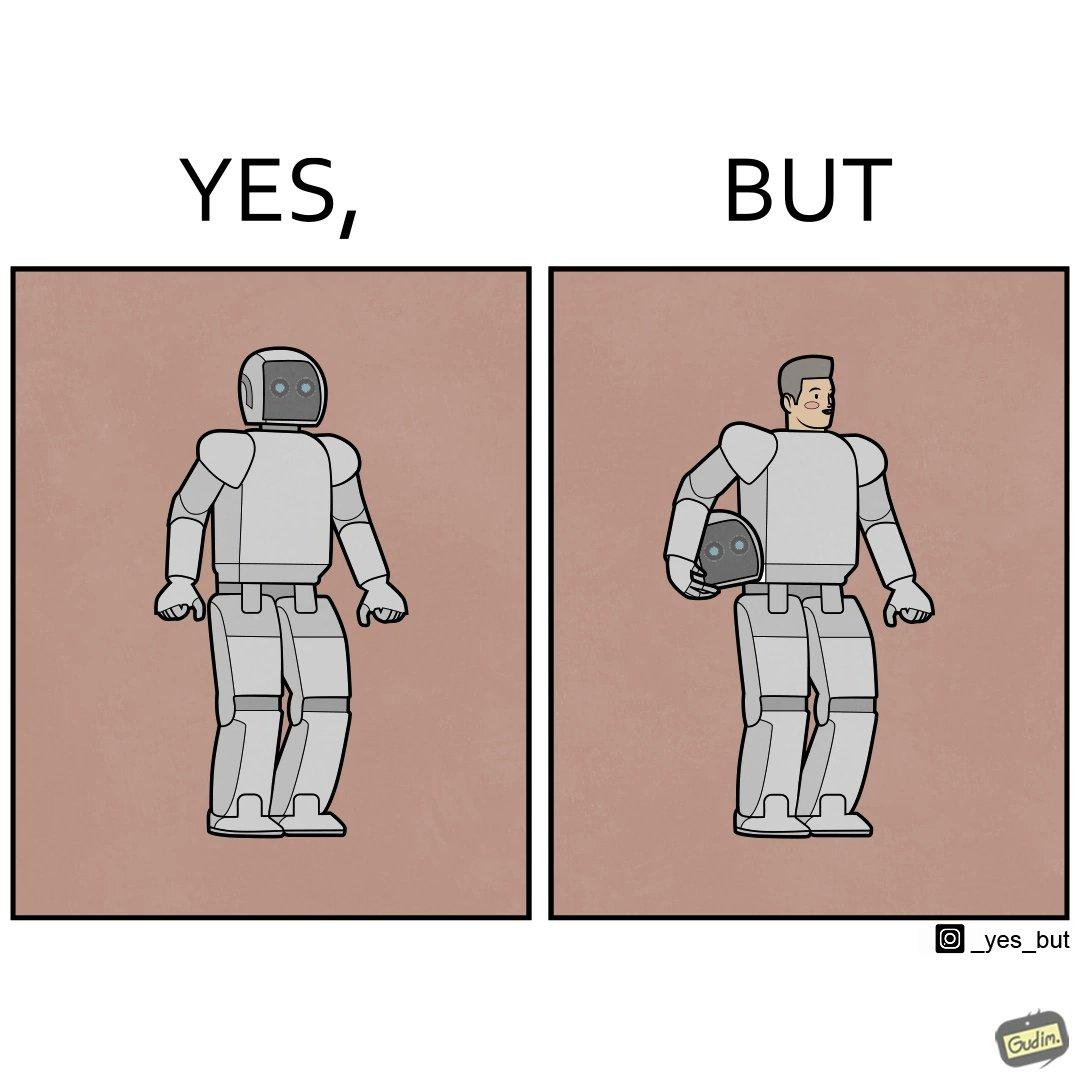Is this image satirical or non-satirical? Yes, this image is satirical. 